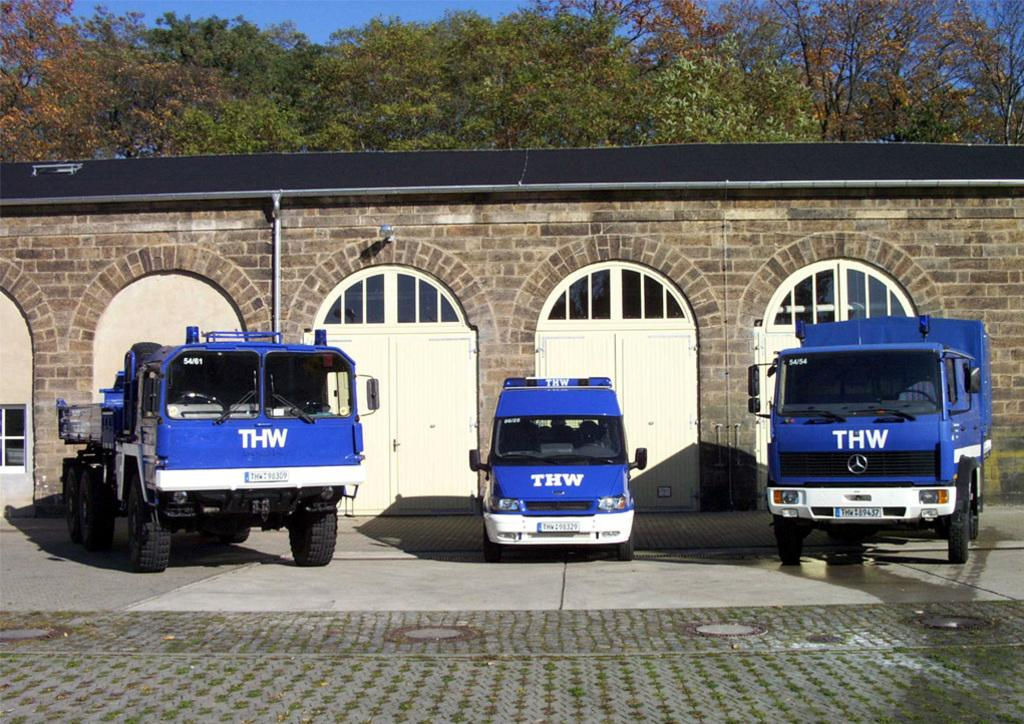What can be seen on the road in the image? There are vehicles on the road in the image. What type of architectural feature is visible in the image? There are doors and a wall visible in the image. What can be seen in the background of the image? There are trees and the sky visible in the background of the image. Can you see a baseball game happening in the image? There is no baseball game present in the image. Is there a hammer being used to build the wall in the image? There is no hammer visible in the image, and the wall's construction is not depicted. 